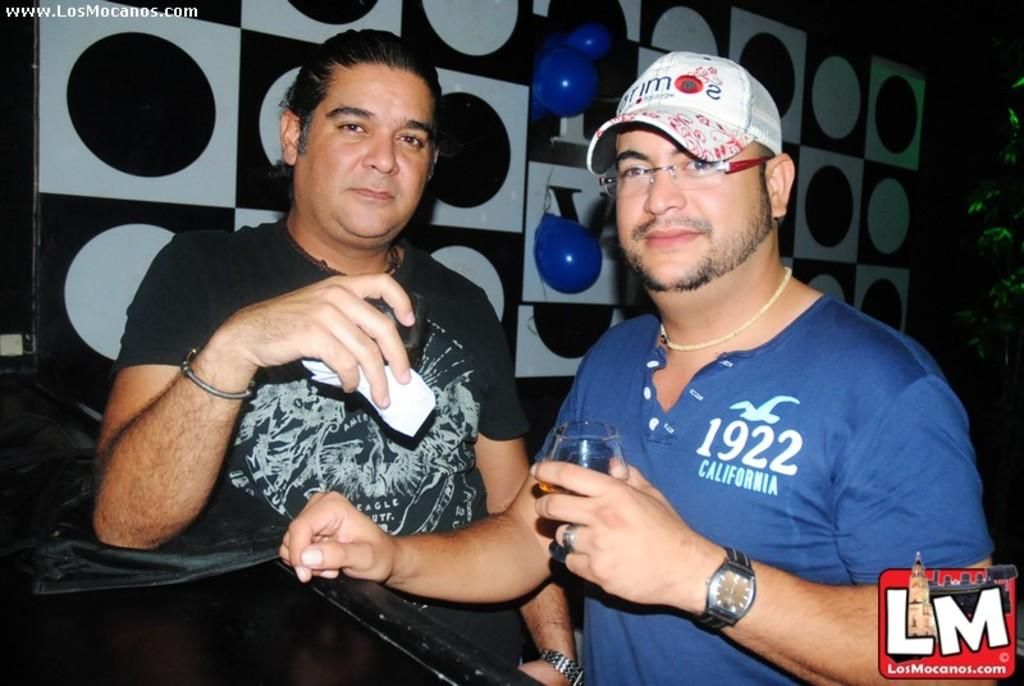How many people are in the image? There are two persons standing in the image. What are the persons holding in their hands? The persons are holding glasses. What can be seen in the background of the image? There are balloons on a board and a plant in the background of the image. Are there any visible marks on the image? Yes, there are watermarks on the image. What type of scent can be smelled coming from the gun in the image? There is no gun present in the image, so it is not possible to determine any scent associated with it. 